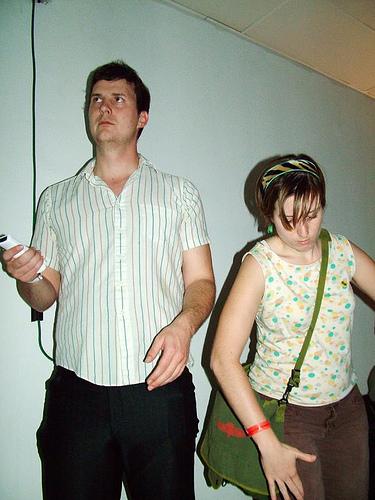How many shirts have stripes?
Keep it brief. 1. How many people have wristbands on their arms?
Give a very brief answer. 1. Is the girl wearing earrings?
Answer briefly. Yes. How many babies are in the house?
Keep it brief. 0. A gambler would suspect which person was winning?
Keep it brief. Man. What color is the woman's bag?
Be succinct. Green. What type of pants is the man on the left wearing?
Write a very short answer. Dress. Are they happy?
Be succinct. No. 